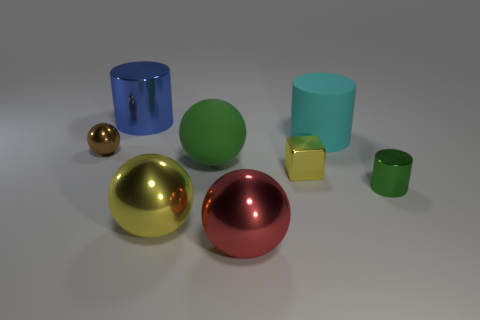Is there any other thing that is the same shape as the small yellow metal object?
Offer a very short reply. No. There is a yellow thing on the left side of the yellow thing that is behind the large yellow thing; what shape is it?
Offer a terse response. Sphere. Are there any other things that are the same color as the small metallic cylinder?
Provide a short and direct response. Yes. How many objects are shiny cylinders or yellow balls?
Ensure brevity in your answer.  3. Is there another metal object that has the same size as the green metallic thing?
Offer a very short reply. Yes. The big cyan rubber object has what shape?
Offer a terse response. Cylinder. Are there more yellow things behind the brown sphere than small yellow cubes behind the small yellow object?
Make the answer very short. No. Does the shiny object that is to the right of the big cyan matte cylinder have the same color as the metal sphere on the left side of the blue object?
Your answer should be very brief. No. There is a brown object that is the same size as the yellow shiny cube; what is its shape?
Offer a very short reply. Sphere. Are there any tiny green objects that have the same shape as the blue thing?
Offer a terse response. Yes. 